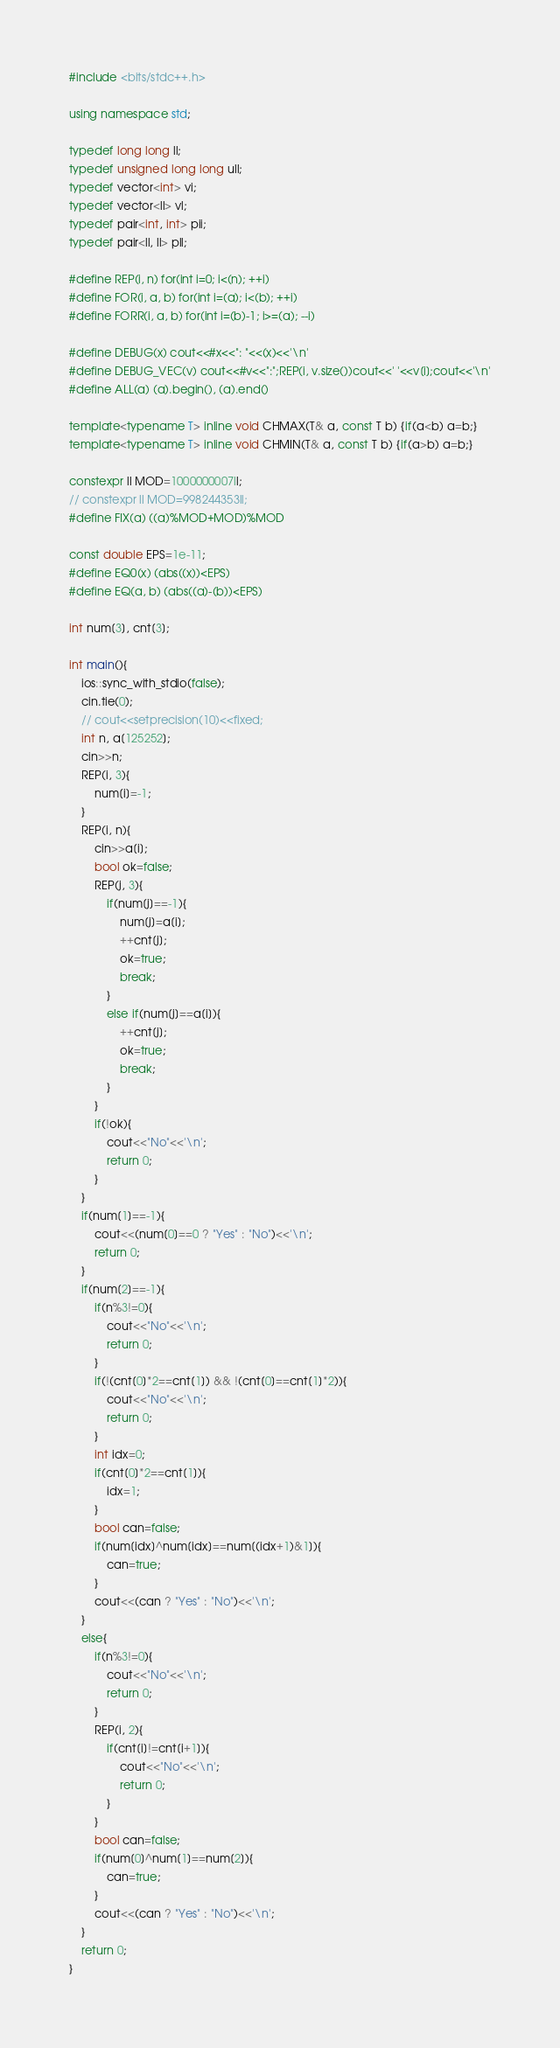<code> <loc_0><loc_0><loc_500><loc_500><_C++_>#include <bits/stdc++.h>

using namespace std;

typedef long long ll;
typedef unsigned long long ull;
typedef vector<int> vi;
typedef vector<ll> vl;
typedef pair<int, int> pii;
typedef pair<ll, ll> pll;

#define REP(i, n) for(int i=0; i<(n); ++i)
#define FOR(i, a, b) for(int i=(a); i<(b); ++i)
#define FORR(i, a, b) for(int i=(b)-1; i>=(a); --i)

#define DEBUG(x) cout<<#x<<": "<<(x)<<'\n'
#define DEBUG_VEC(v) cout<<#v<<":";REP(i, v.size())cout<<' '<<v[i];cout<<'\n'
#define ALL(a) (a).begin(), (a).end()

template<typename T> inline void CHMAX(T& a, const T b) {if(a<b) a=b;}
template<typename T> inline void CHMIN(T& a, const T b) {if(a>b) a=b;}

constexpr ll MOD=1000000007ll;
// constexpr ll MOD=998244353ll;
#define FIX(a) ((a)%MOD+MOD)%MOD

const double EPS=1e-11;
#define EQ0(x) (abs((x))<EPS)
#define EQ(a, b) (abs((a)-(b))<EPS)

int num[3], cnt[3];

int main(){
	ios::sync_with_stdio(false);
	cin.tie(0);
	// cout<<setprecision(10)<<fixed;
	int n, a[125252];
	cin>>n;
	REP(i, 3){
		num[i]=-1;
	}
	REP(i, n){
		cin>>a[i];
		bool ok=false;
		REP(j, 3){
			if(num[j]==-1){
				num[j]=a[i];
				++cnt[j];
				ok=true;
				break;
			}
			else if(num[j]==a[i]){
				++cnt[j];
				ok=true;
				break;
			}
		}
		if(!ok){
			cout<<"No"<<'\n';
			return 0;
		}
	}
	if(num[1]==-1){
		cout<<(num[0]==0 ? "Yes" : "No")<<'\n';
		return 0;
	}
	if(num[2]==-1){
		if(n%3!=0){
			cout<<"No"<<'\n';
			return 0;
		}
		if(!(cnt[0]*2==cnt[1]) && !(cnt[0]==cnt[1]*2)){
			cout<<"No"<<'\n';
			return 0;
		}
		int idx=0;
		if(cnt[0]*2==cnt[1]){
			idx=1;
		}
		bool can=false;
		if(num[idx]^num[idx]==num[(idx+1)&1]){
			can=true;
		}
		cout<<(can ? "Yes" : "No")<<'\n';
	}
	else{
		if(n%3!=0){
			cout<<"No"<<'\n';
			return 0;
		}
		REP(i, 2){
			if(cnt[i]!=cnt[i+1]){
				cout<<"No"<<'\n';
				return 0;
			}
		}
		bool can=false;
		if(num[0]^num[1]==num[2]){
			can=true;
		}
		cout<<(can ? "Yes" : "No")<<'\n';
	}
	return 0;
}
</code> 